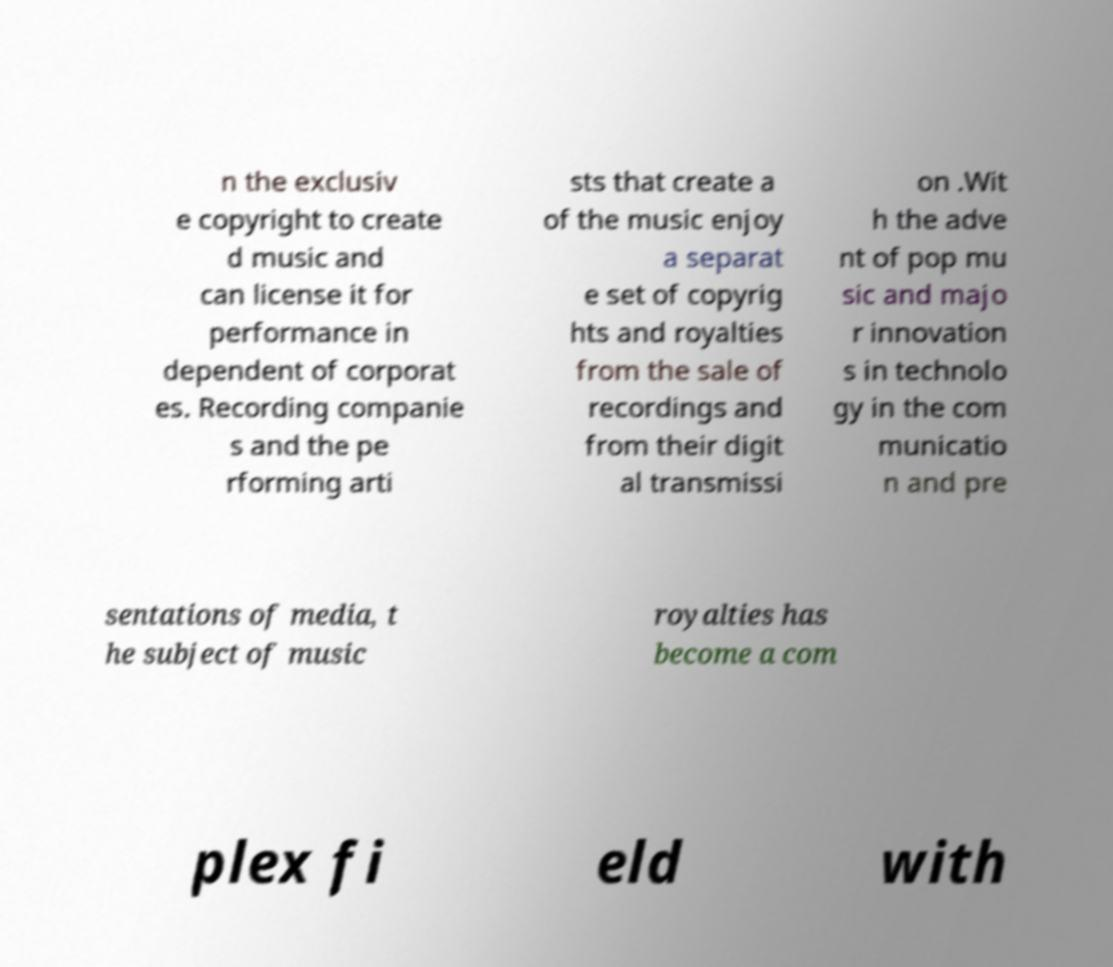I need the written content from this picture converted into text. Can you do that? n the exclusiv e copyright to create d music and can license it for performance in dependent of corporat es. Recording companie s and the pe rforming arti sts that create a of the music enjoy a separat e set of copyrig hts and royalties from the sale of recordings and from their digit al transmissi on .Wit h the adve nt of pop mu sic and majo r innovation s in technolo gy in the com municatio n and pre sentations of media, t he subject of music royalties has become a com plex fi eld with 